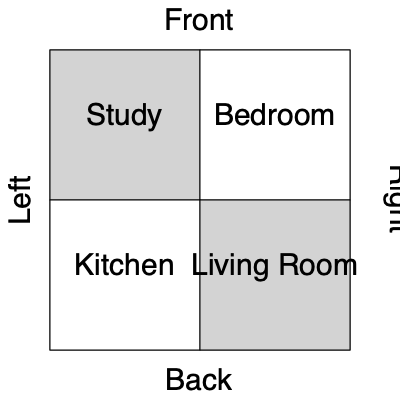In this floor plan of a writer's retreat, if you were to rotate the building 90 degrees clockwise when viewed from above, which room would now be at the front right corner? To solve this problem, let's follow these steps:

1. Understand the current layout:
   - The study is in the front left corner
   - The bedroom is in the front right corner
   - The kitchen is in the back left corner
   - The living room is in the back right corner

2. Visualize a 90-degree clockwise rotation:
   - The front of the building will become the right side
   - The right side will become the back
   - The back will become the left side
   - The left side will become the front

3. Track the movement of each room:
   - The study (front left) will move to the front right
   - The bedroom (front right) will move to the back right
   - The kitchen (back left) will move to the front left
   - The living room (back right) will move to the back left

4. Identify the new front right corner:
   - After the rotation, the study will occupy this position

Therefore, after a 90-degree clockwise rotation, the study will be in the front right corner of the writer's retreat.
Answer: Study 